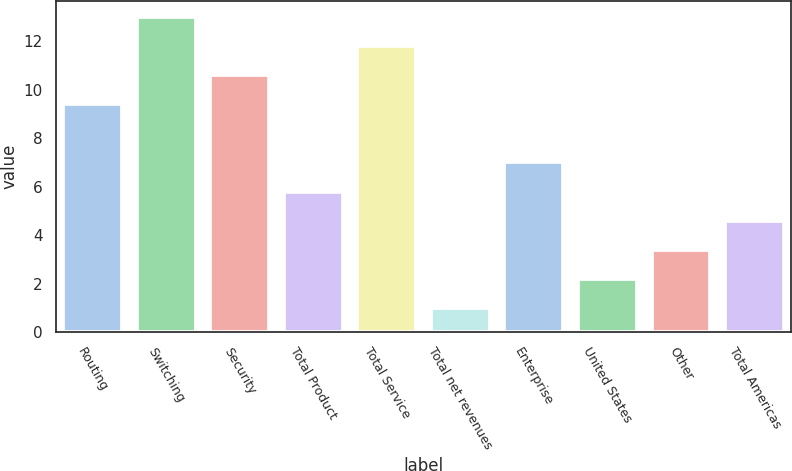Convert chart to OTSL. <chart><loc_0><loc_0><loc_500><loc_500><bar_chart><fcel>Routing<fcel>Switching<fcel>Security<fcel>Total Product<fcel>Total Service<fcel>Total net revenues<fcel>Enterprise<fcel>United States<fcel>Other<fcel>Total Americas<nl><fcel>9.4<fcel>13<fcel>10.6<fcel>5.8<fcel>11.8<fcel>1<fcel>7<fcel>2.2<fcel>3.4<fcel>4.6<nl></chart> 